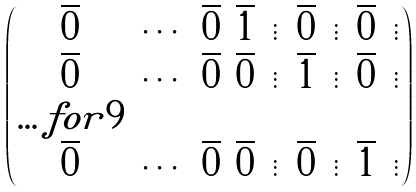<formula> <loc_0><loc_0><loc_500><loc_500>\begin{pmatrix} \overline { 0 } & \cdots & \overline { 0 } & \overline { 1 } & \vdots & \overline { 0 } & \vdots & \overline { 0 } & \vdots \\ \overline { 0 } & \cdots & \overline { 0 } & \overline { 0 } & \vdots & \overline { 1 } & \vdots & \overline { 0 } & \vdots \\ \hdots f o r { 9 } \\ \overline { 0 } & \cdots & \overline { 0 } & \overline { 0 } & \vdots & \overline { 0 } & \vdots & \overline { 1 } & \vdots \\ \end{pmatrix}</formula> 